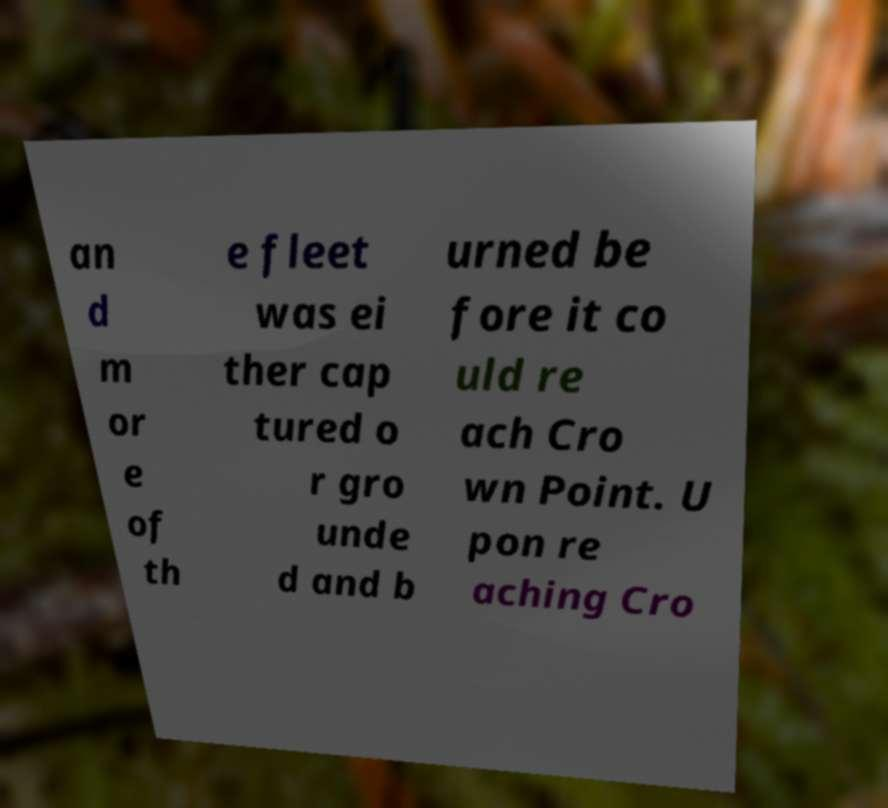Please identify and transcribe the text found in this image. an d m or e of th e fleet was ei ther cap tured o r gro unde d and b urned be fore it co uld re ach Cro wn Point. U pon re aching Cro 